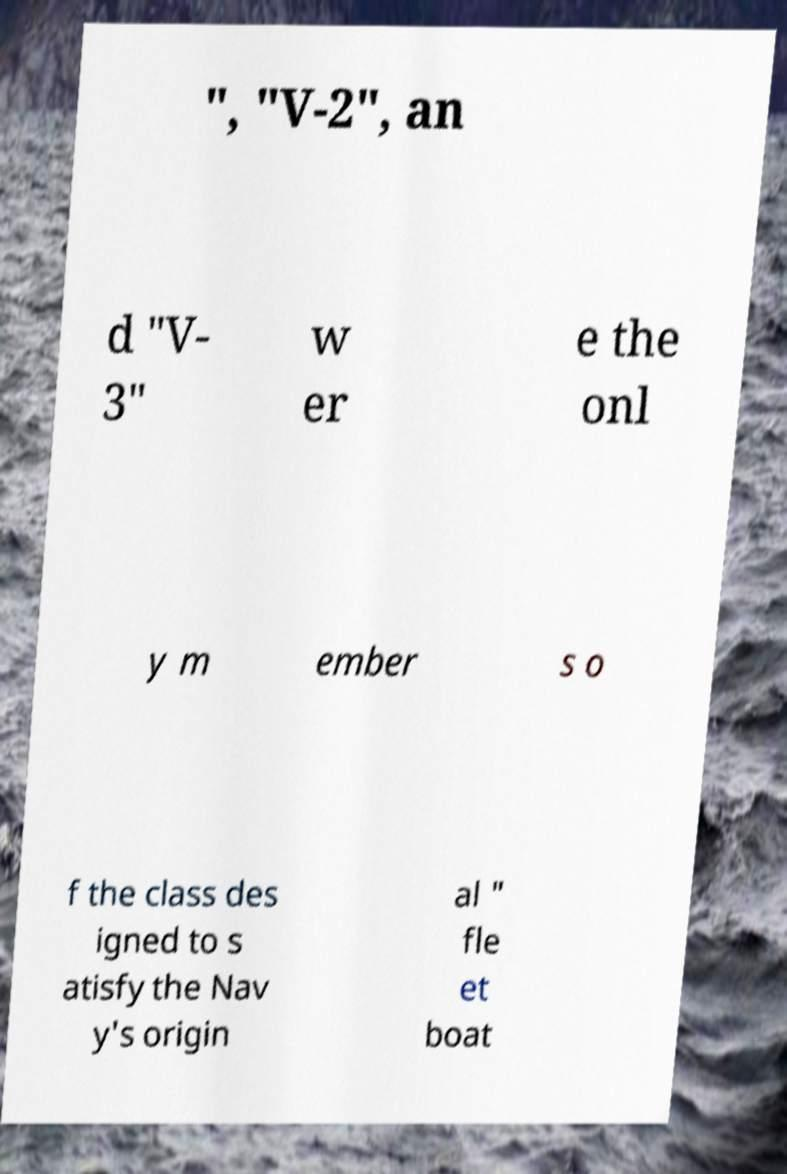Could you assist in decoding the text presented in this image and type it out clearly? ", "V-2", an d "V- 3" w er e the onl y m ember s o f the class des igned to s atisfy the Nav y's origin al " fle et boat 